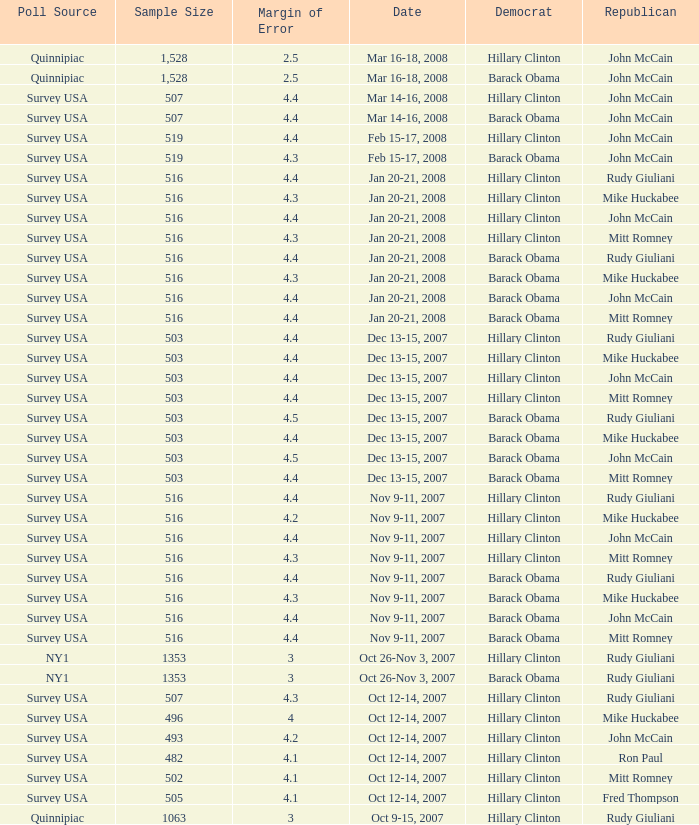Which Democrat was selected in the poll with a sample size smaller than 516 where the Republican chosen was Ron Paul? Hillary Clinton. 